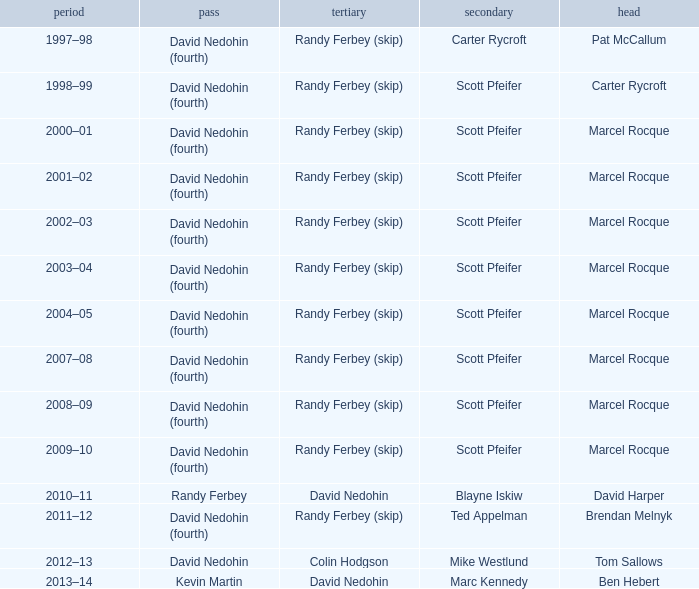Which Second has a Lead of ben hebert? Marc Kennedy. 